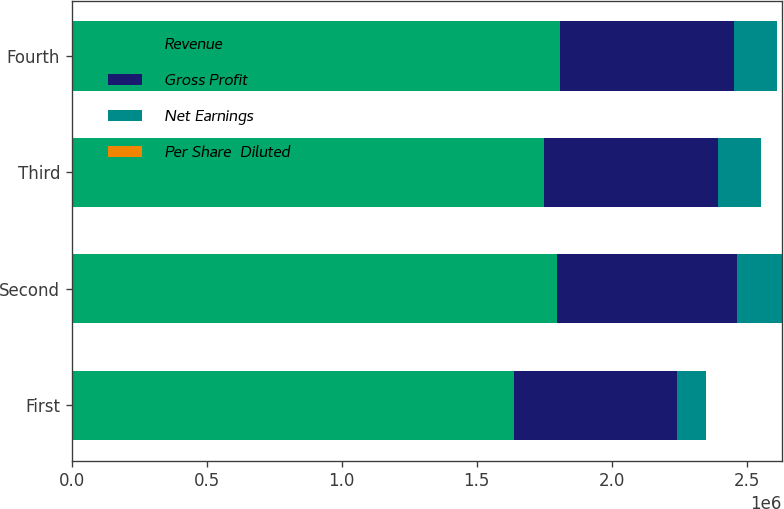Convert chart to OTSL. <chart><loc_0><loc_0><loc_500><loc_500><stacked_bar_chart><ecel><fcel>First<fcel>Second<fcel>Third<fcel>Fourth<nl><fcel>Revenue<fcel>1.63767e+06<fcel>1.79809e+06<fcel>1.7474e+06<fcel>1.80895e+06<nl><fcel>Gross Profit<fcel>602828<fcel>665236<fcel>646520<fcel>644972<nl><fcel>Net Earnings<fcel>109409<fcel>166456<fcel>157305<fcel>157975<nl><fcel>Per Share  Diluted<fcel>0.71<fcel>1.1<fcel>1.07<fcel>1.08<nl></chart> 